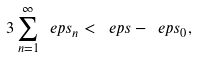Convert formula to latex. <formula><loc_0><loc_0><loc_500><loc_500>3 \sum _ { n = 1 } ^ { \infty } \ e p s _ { n } < \ e p s - \ e p s _ { 0 } ,</formula> 